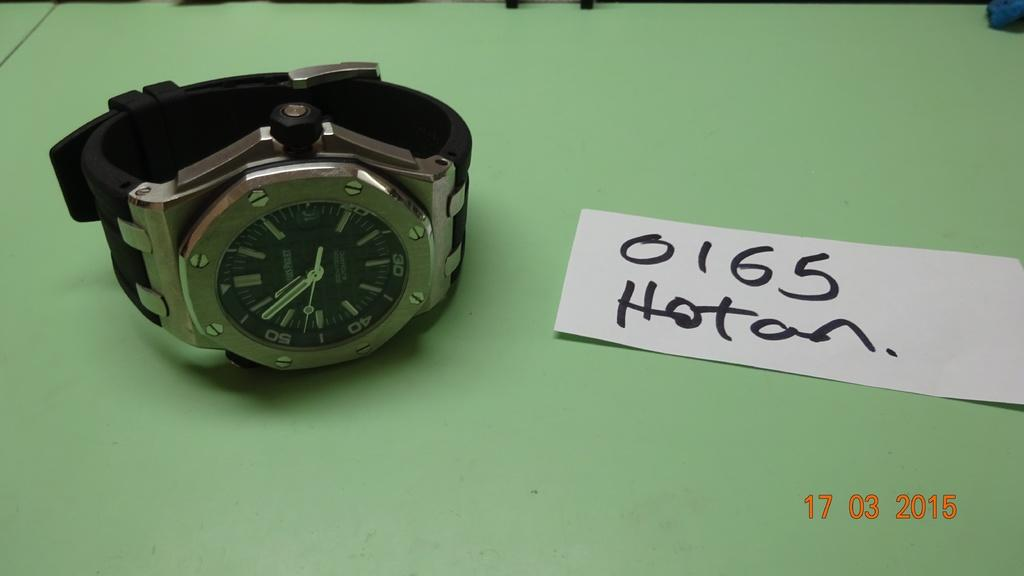<image>
Offer a succinct explanation of the picture presented. A watch sits on a green table next to a card that reads 0165 Hotan. 